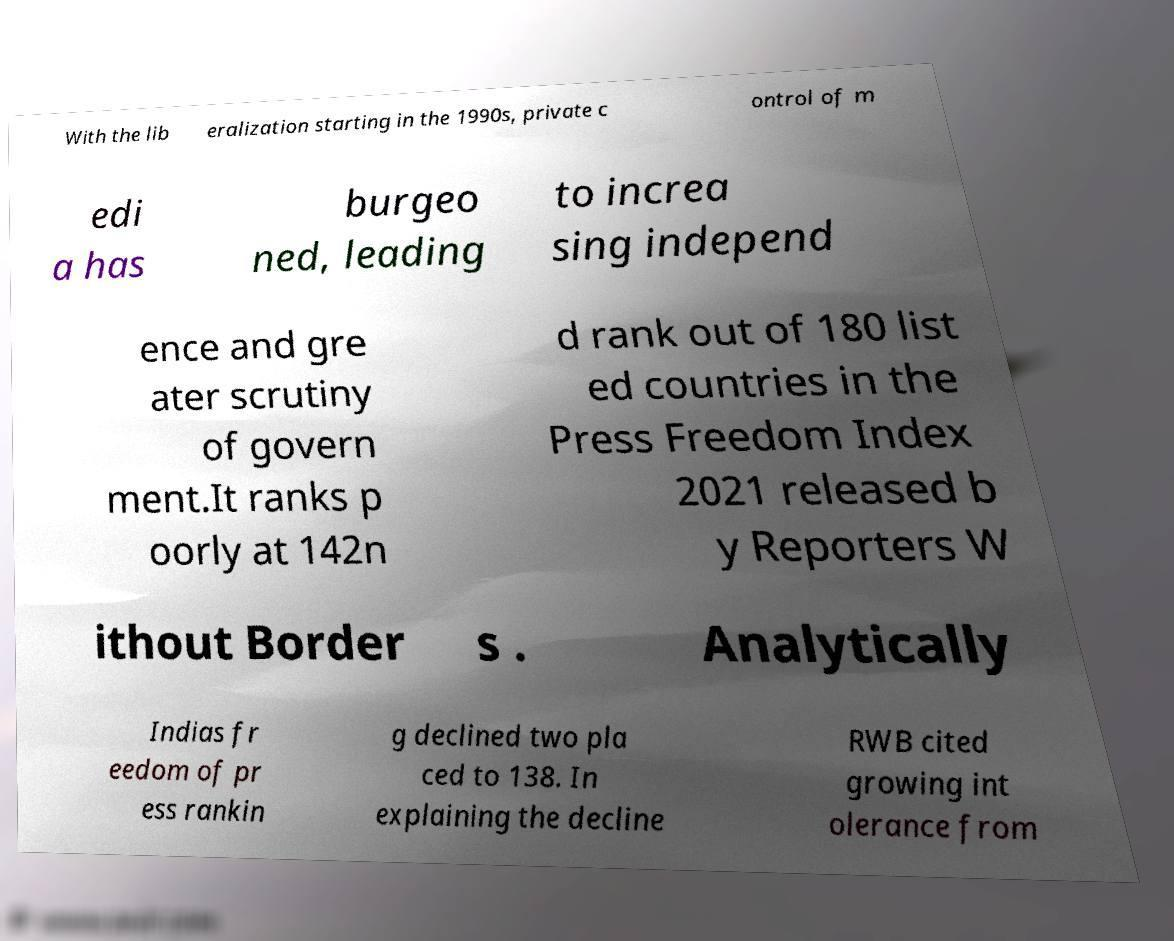Could you extract and type out the text from this image? With the lib eralization starting in the 1990s, private c ontrol of m edi a has burgeo ned, leading to increa sing independ ence and gre ater scrutiny of govern ment.It ranks p oorly at 142n d rank out of 180 list ed countries in the Press Freedom Index 2021 released b y Reporters W ithout Border s . Analytically Indias fr eedom of pr ess rankin g declined two pla ced to 138. In explaining the decline RWB cited growing int olerance from 